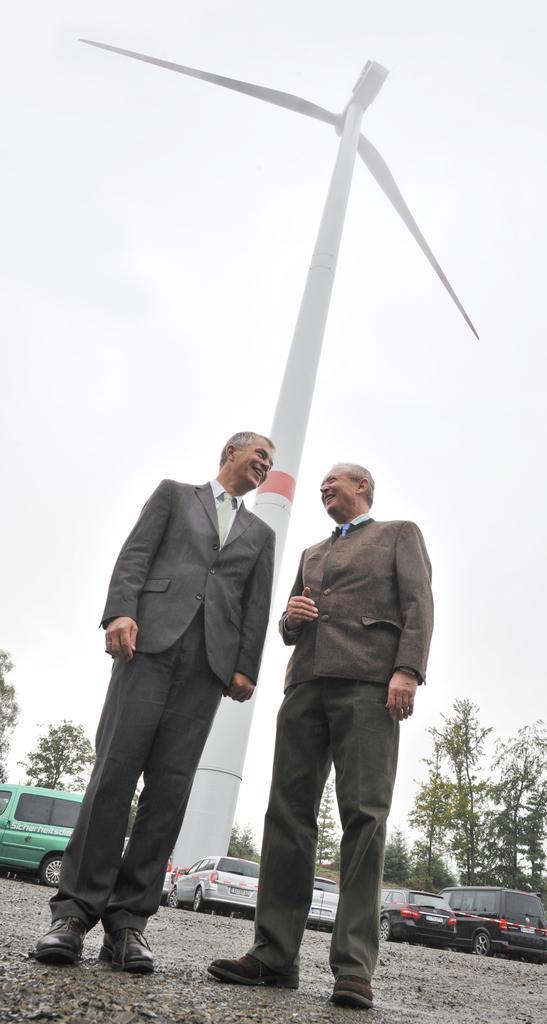Please provide a concise description of this image. There are two persons standing. In the back there are vehicles, wind fan, trees and sky. 